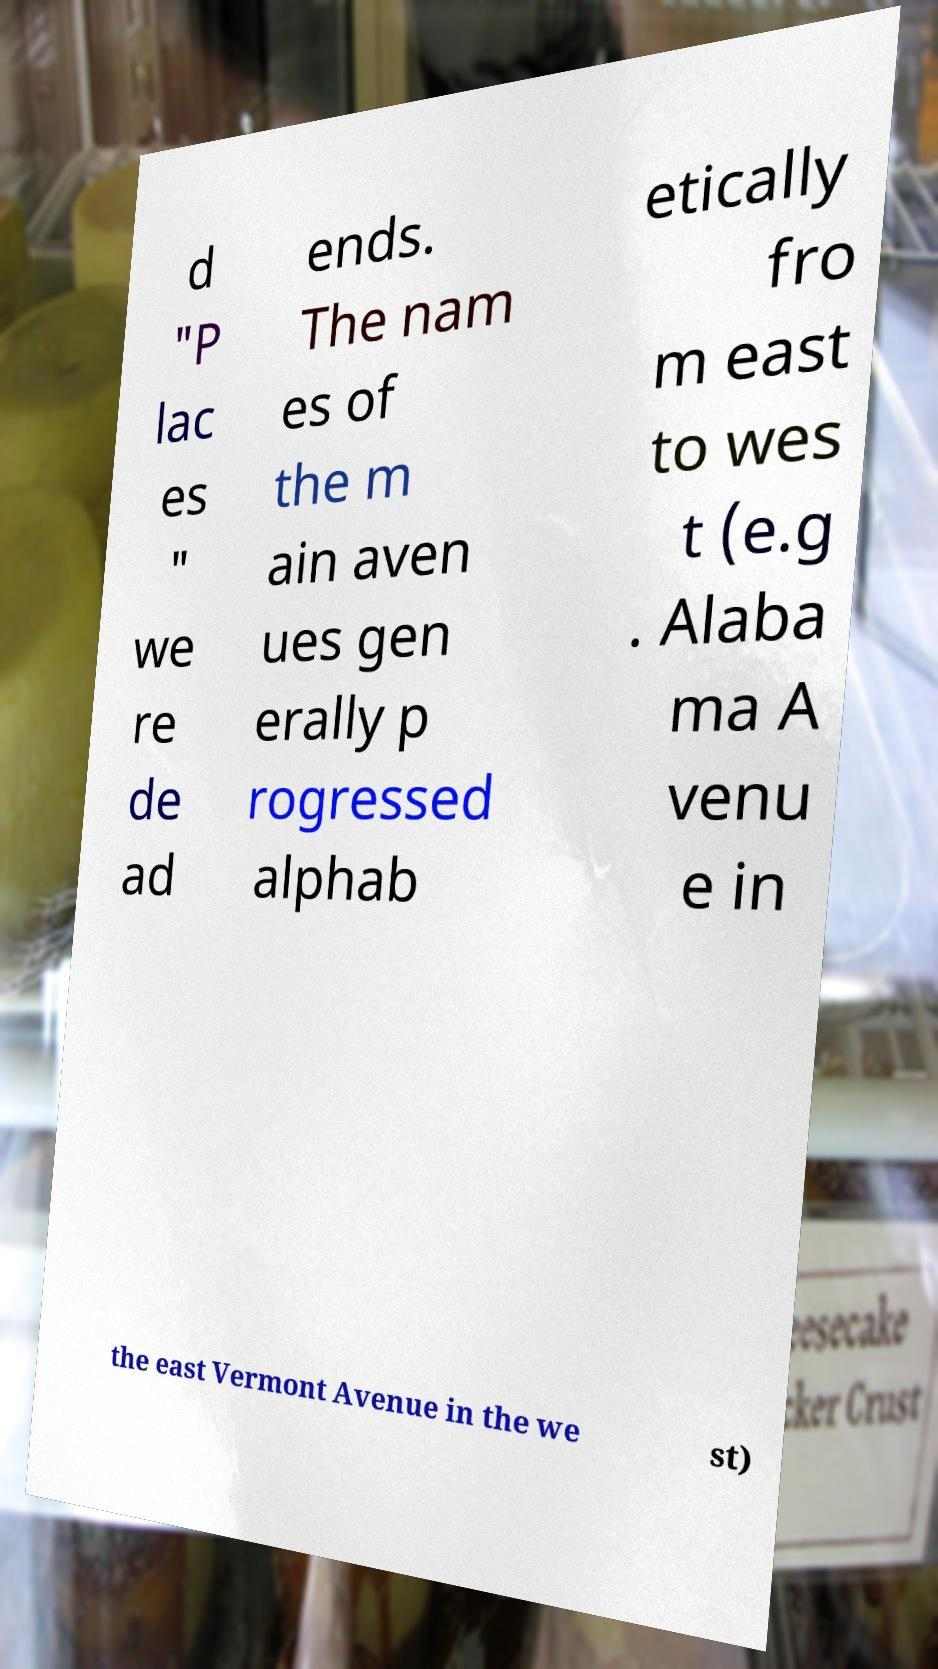Please read and relay the text visible in this image. What does it say? d "P lac es " we re de ad ends. The nam es of the m ain aven ues gen erally p rogressed alphab etically fro m east to wes t (e.g . Alaba ma A venu e in the east Vermont Avenue in the we st) 